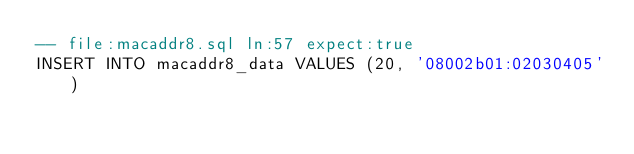Convert code to text. <code><loc_0><loc_0><loc_500><loc_500><_SQL_>-- file:macaddr8.sql ln:57 expect:true
INSERT INTO macaddr8_data VALUES (20, '08002b01:02030405')
</code> 